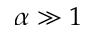<formula> <loc_0><loc_0><loc_500><loc_500>\alpha \gg 1</formula> 